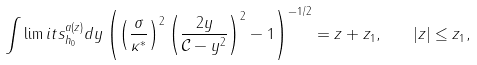<formula> <loc_0><loc_0><loc_500><loc_500>\int \lim i t s _ { h _ { 0 } } ^ { a ( z ) } d y \left ( \left ( \frac { \sigma } { \kappa ^ { * } } \right ) ^ { 2 } \left ( \frac { 2 y } { { \mathcal { C } } - y ^ { 2 } } \right ) ^ { 2 } - 1 \right ) ^ { - 1 / 2 } = z + z _ { 1 } , \quad | z | \leq z _ { 1 } ,</formula> 